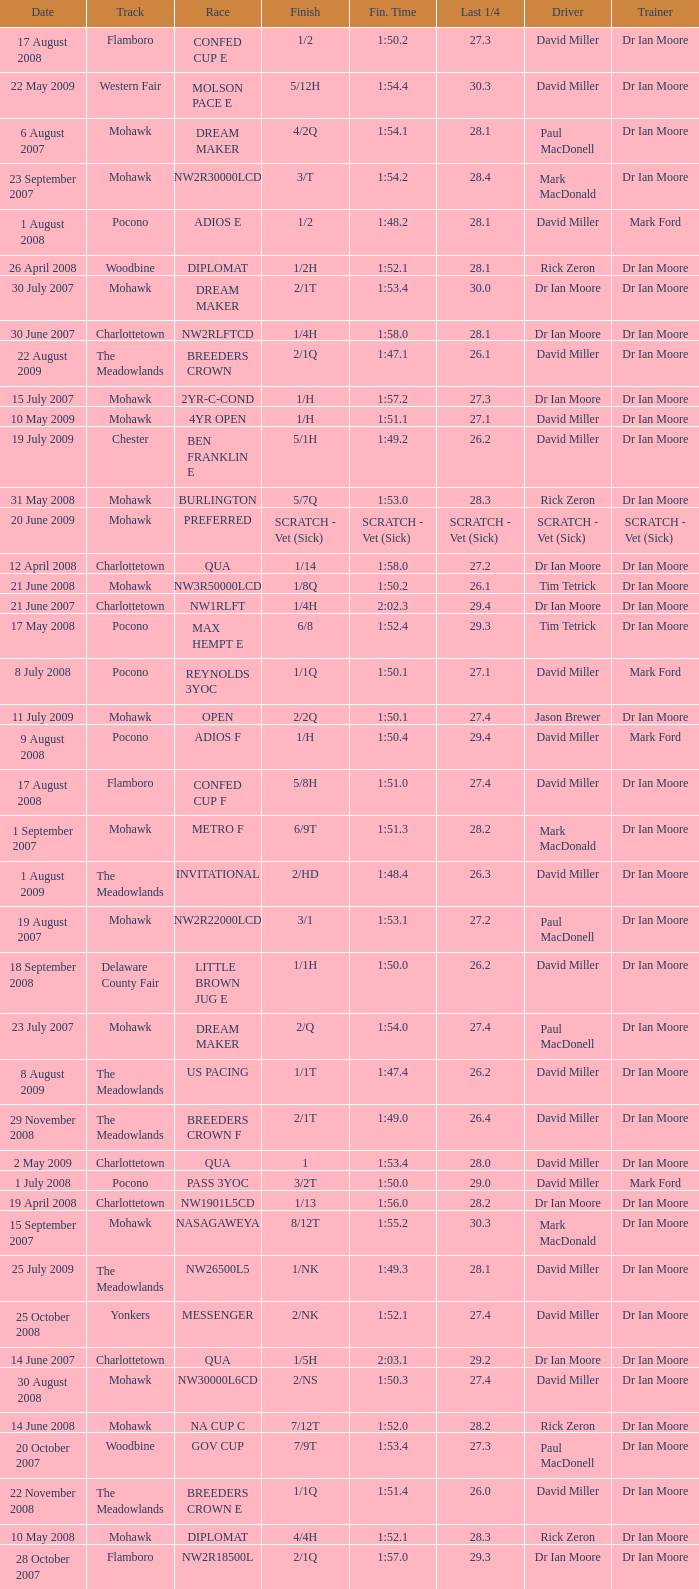What is the finishing time with a 2/1q finish on the Meadowlands track? 1:47.1. 